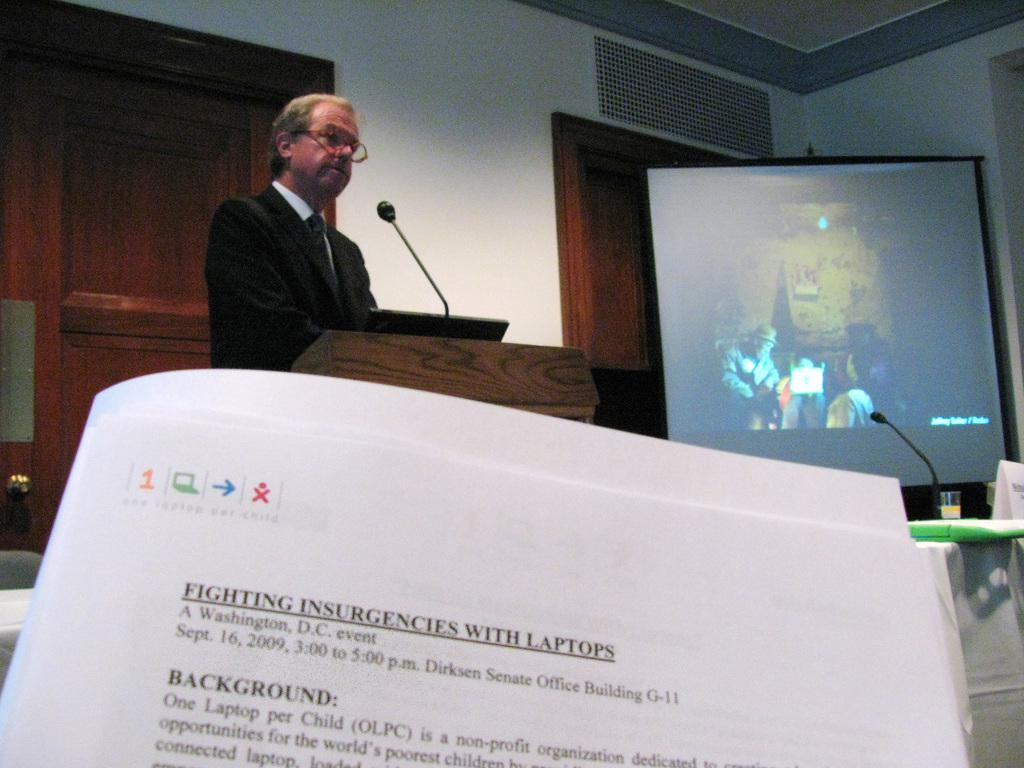<image>
Share a concise interpretation of the image provided. A packet of paper with the words fighting insurgencies with laptops at the top 